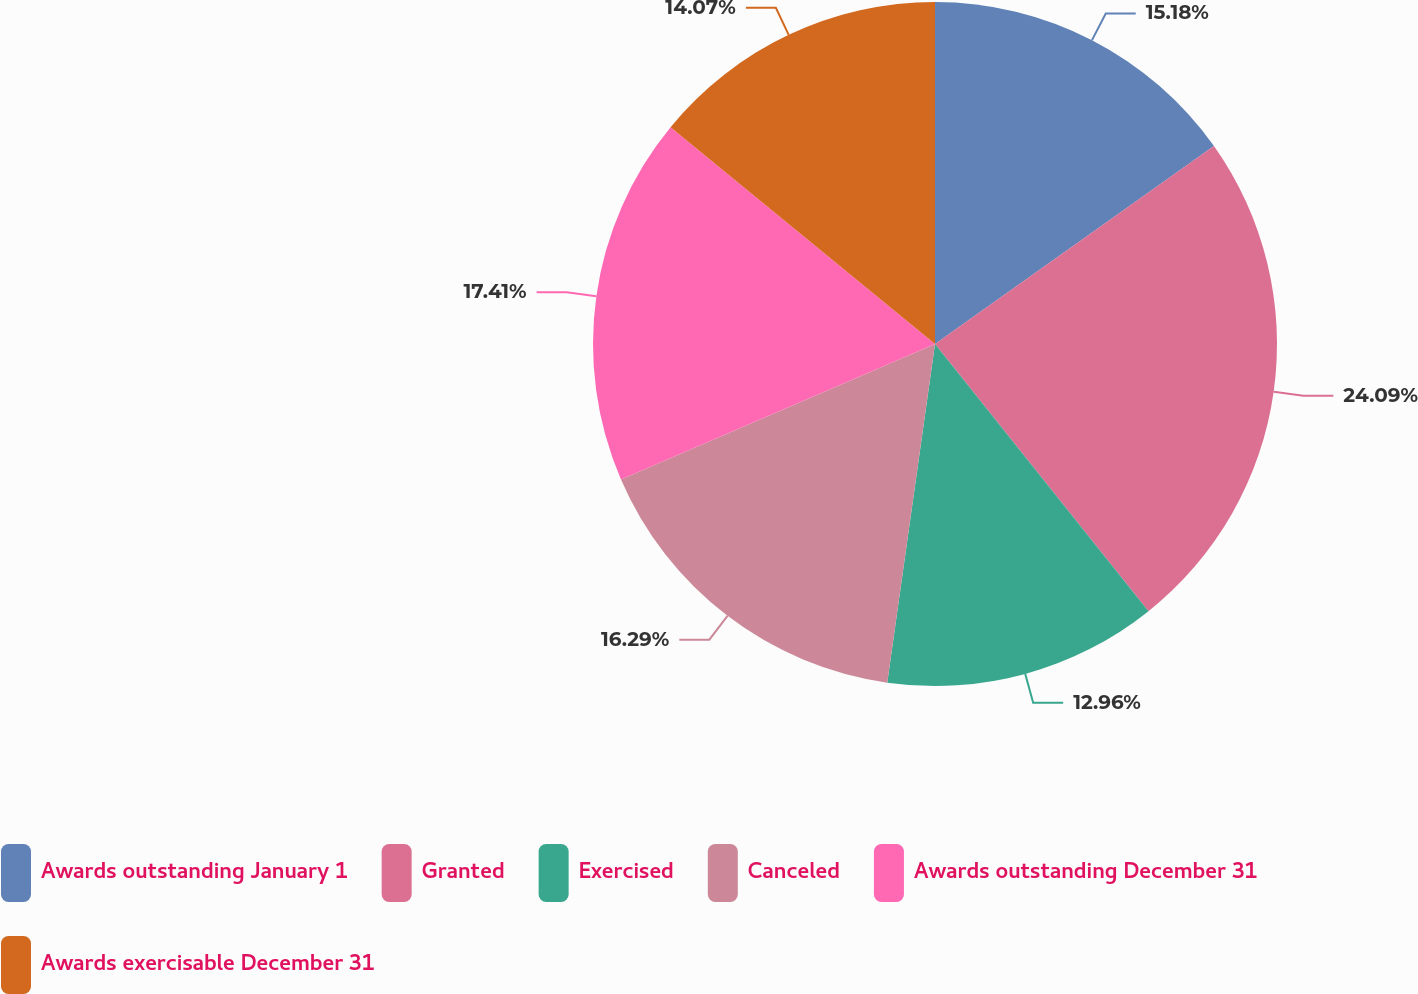Convert chart to OTSL. <chart><loc_0><loc_0><loc_500><loc_500><pie_chart><fcel>Awards outstanding January 1<fcel>Granted<fcel>Exercised<fcel>Canceled<fcel>Awards outstanding December 31<fcel>Awards exercisable December 31<nl><fcel>15.18%<fcel>24.09%<fcel>12.96%<fcel>16.29%<fcel>17.41%<fcel>14.07%<nl></chart> 